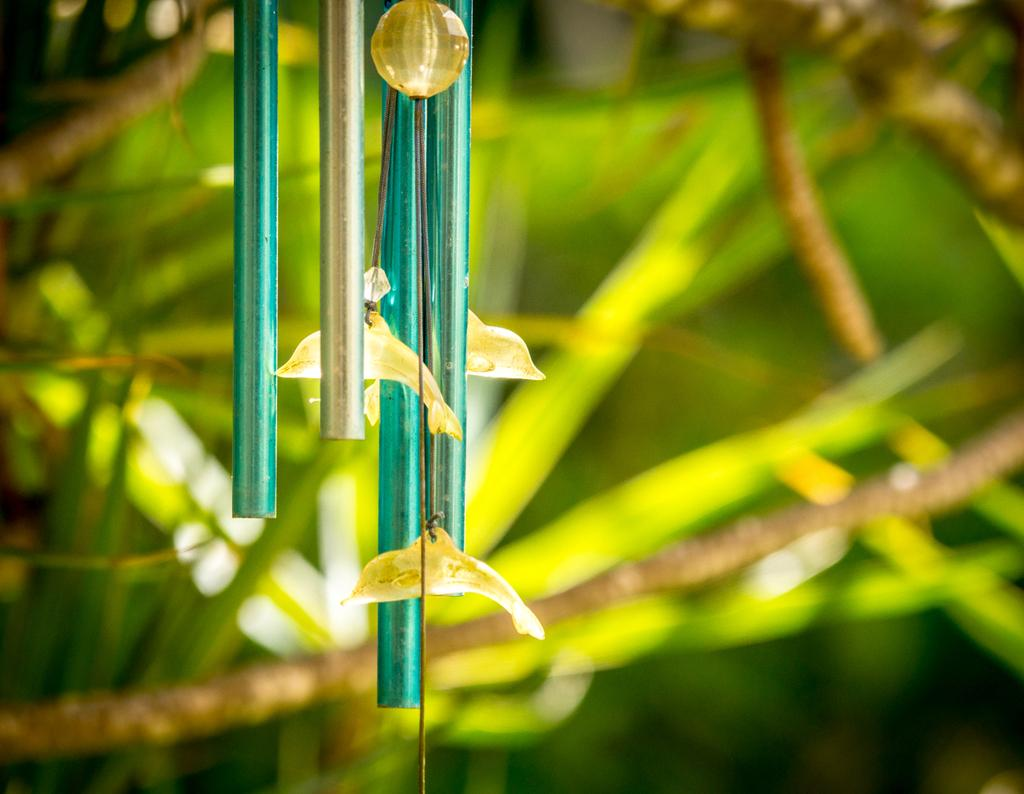What object is located on the left side of the image? There is a wind chime on the left side of the image. What colors are the pipe pieces of the wind chime? The pipe pieces of the wind chime have green and silver colors. What decorative elements are present on the wind chime? The wind chime has toy fishes and a bead connected to the threads. How would you describe the background of the image? The background of the image is blurred. What type of haircut does the beetle in the image have? There is no beetle present in the image, and therefore no haircut can be observed. How does the ray in the image interact with the wind chime? There is no ray present in the image, so it cannot interact with the wind chime. 